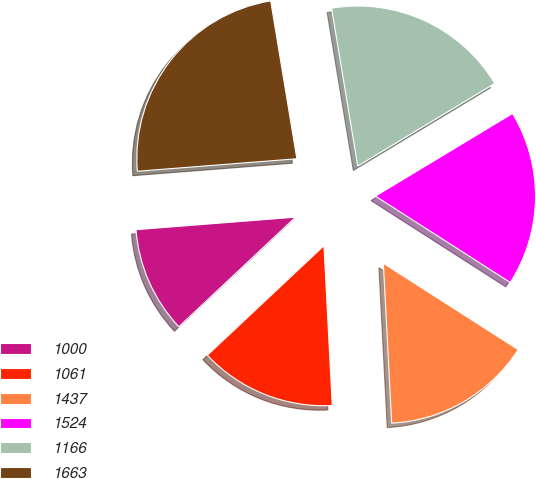Convert chart. <chart><loc_0><loc_0><loc_500><loc_500><pie_chart><fcel>1000<fcel>1061<fcel>1437<fcel>1524<fcel>1166<fcel>1663<nl><fcel>10.76%<fcel>13.82%<fcel>15.11%<fcel>17.7%<fcel>18.98%<fcel>23.63%<nl></chart> 